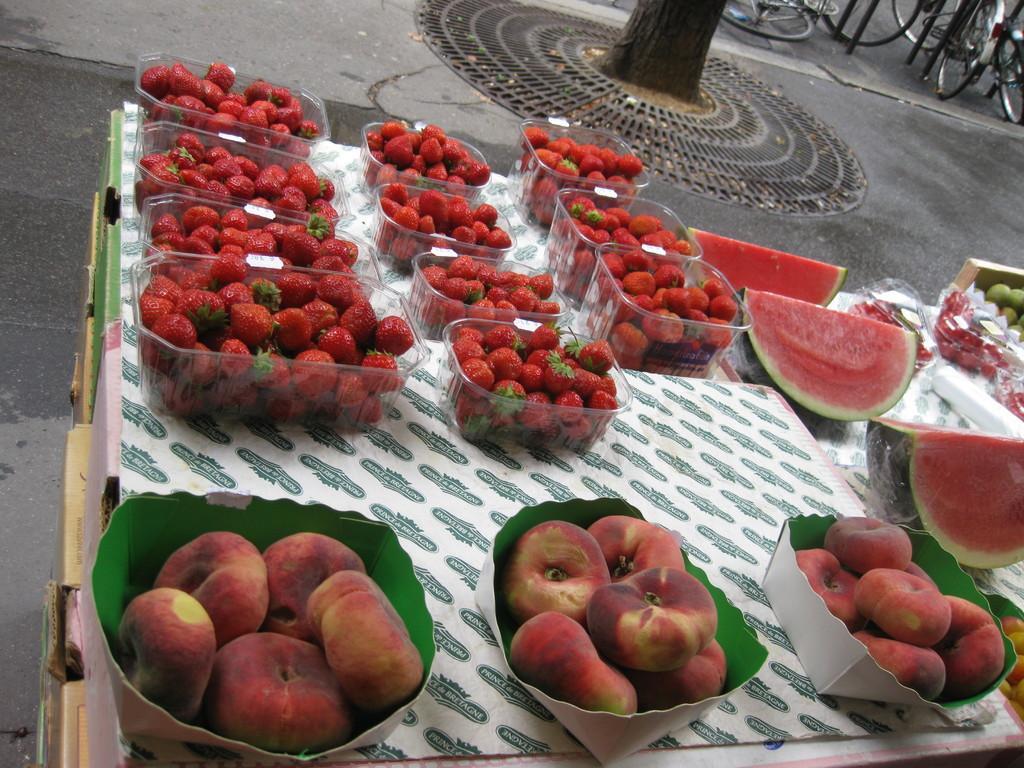Describe this image in one or two sentences. In this image we can see strawberries are arranged in different containers. At the bottom of the image, we can see fruits are there in the boxes. There are watermelons and other fruits on the right side of the image. We can see bicycles and the bark of the tree at the top of the image. 